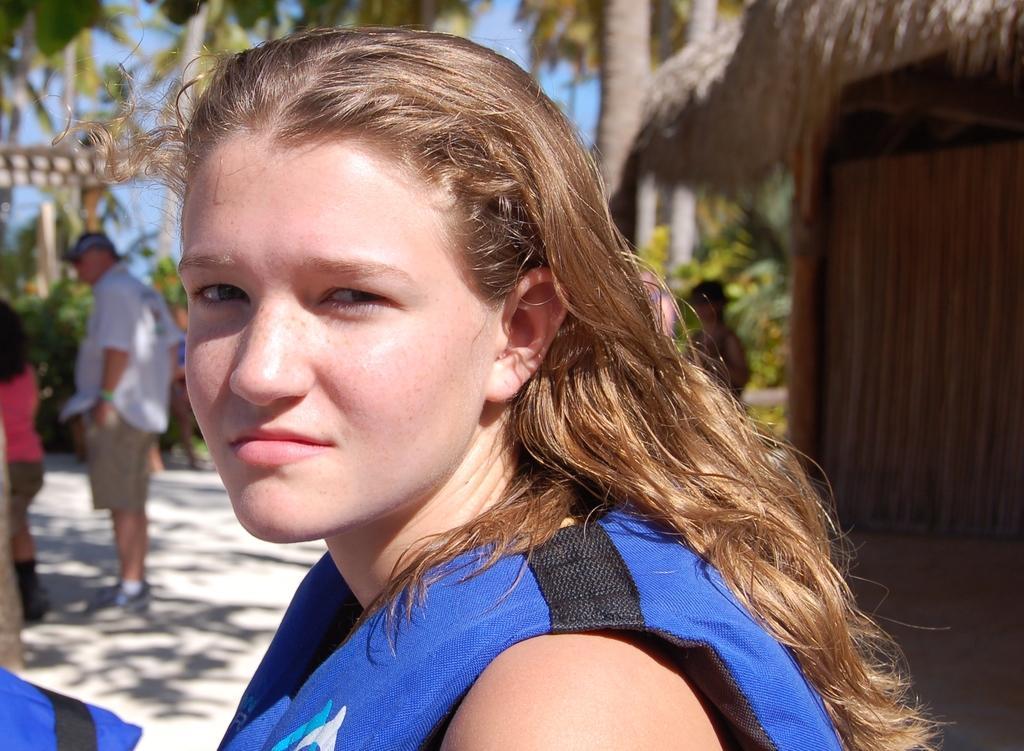Describe this image in one or two sentences. In this picture we can see a person. There are a few people standing on the path. We can see the shadows of some objects on the ground. There are plants, trees, other objects and the sky in the background. 